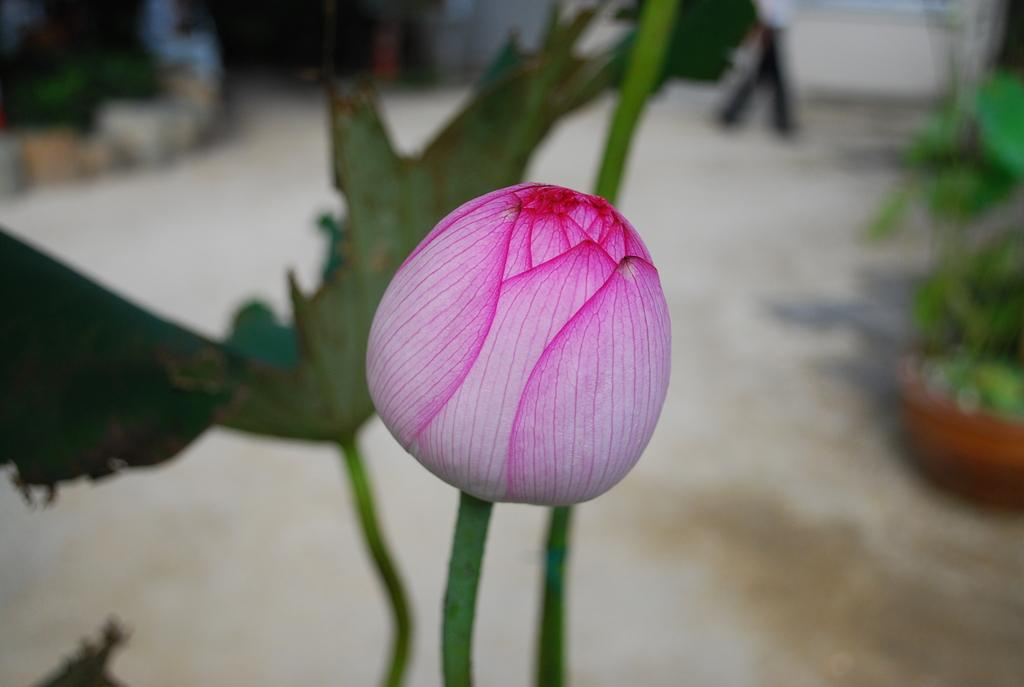What is the main subject of the image? There is a flower in the image. Can you describe the background of the image? The background of the image is blurred. What type of reaction is the flower undergoing in the image? There is no indication in the image that the flower is undergoing any specific reaction. How does the flower aid in the digestion process in the image? The image does not depict any digestion process, nor does it show the flower being used for that purpose. 